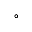<formula> <loc_0><loc_0><loc_500><loc_500>^ { \circ }</formula> 